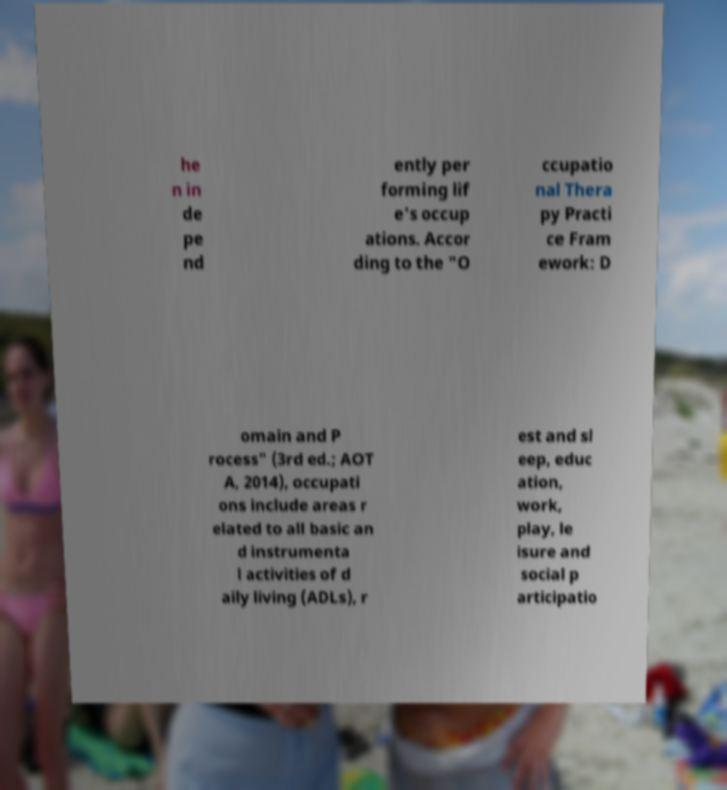Please identify and transcribe the text found in this image. he n in de pe nd ently per forming lif e's occup ations. Accor ding to the "O ccupatio nal Thera py Practi ce Fram ework: D omain and P rocess" (3rd ed.; AOT A, 2014), occupati ons include areas r elated to all basic an d instrumenta l activities of d aily living (ADLs), r est and sl eep, educ ation, work, play, le isure and social p articipatio 